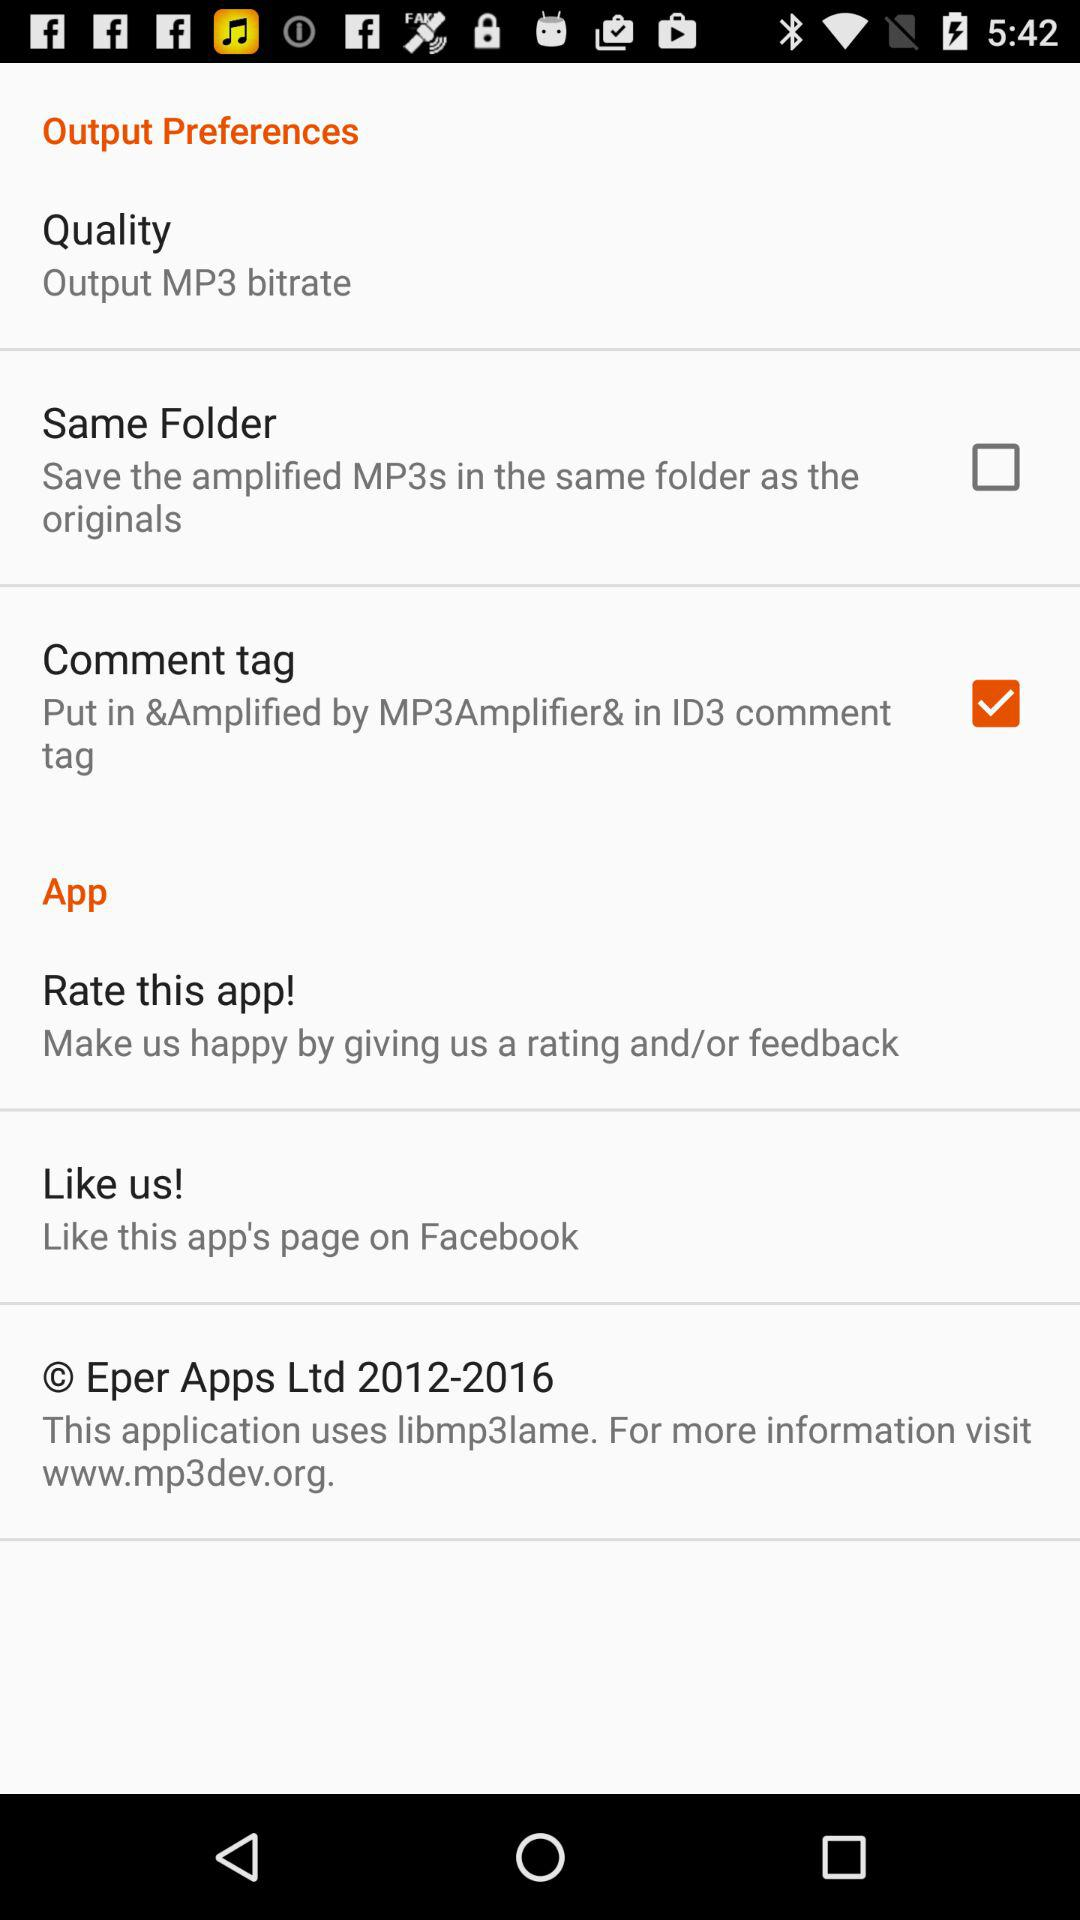Which is the selected checkbox? The selected checkbox is "Comment tag". 